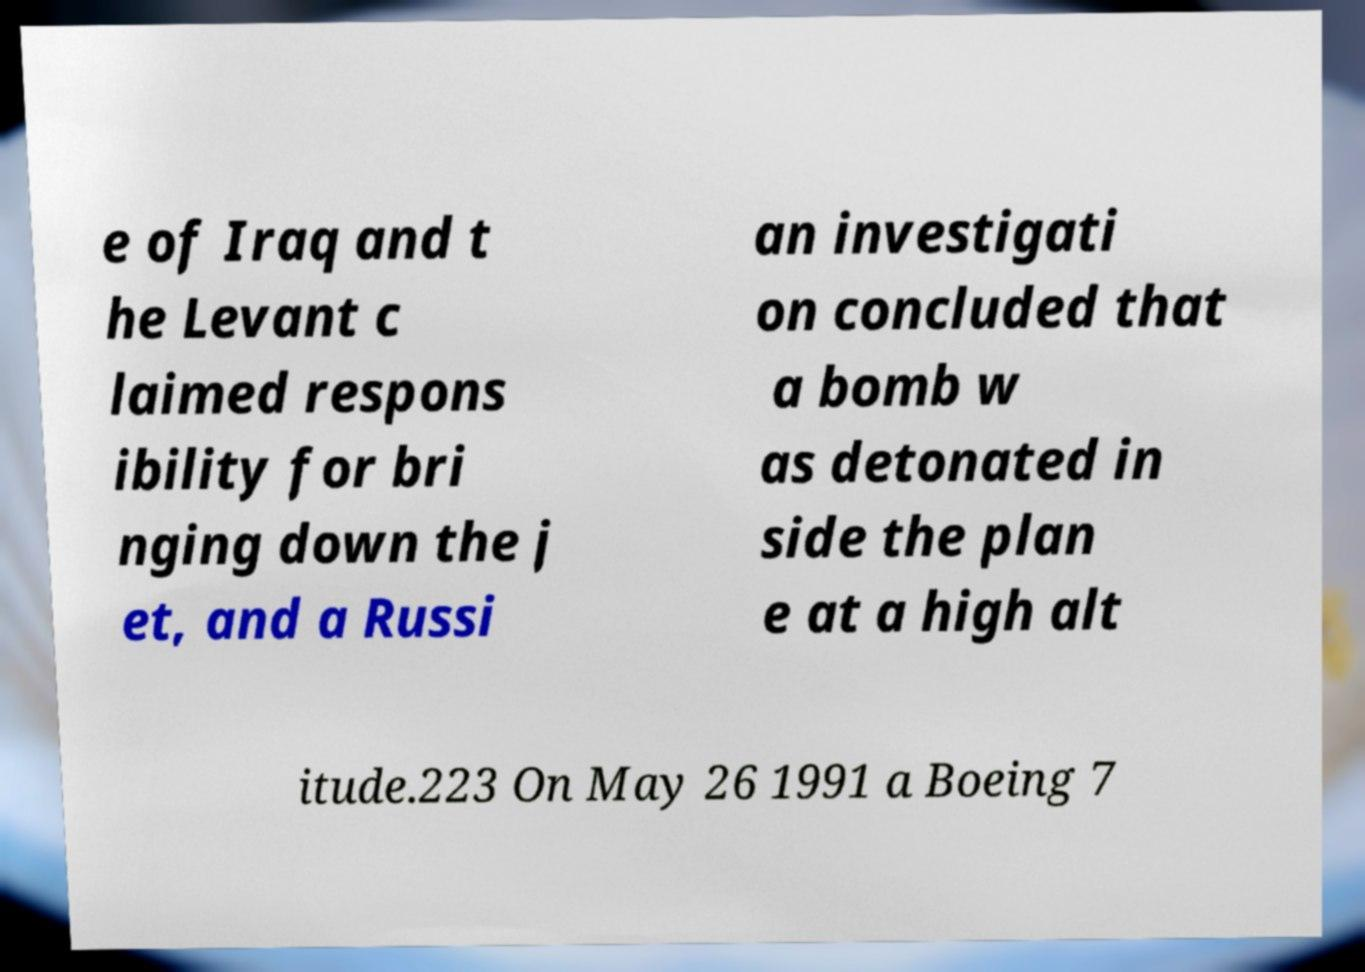Please read and relay the text visible in this image. What does it say? e of Iraq and t he Levant c laimed respons ibility for bri nging down the j et, and a Russi an investigati on concluded that a bomb w as detonated in side the plan e at a high alt itude.223 On May 26 1991 a Boeing 7 